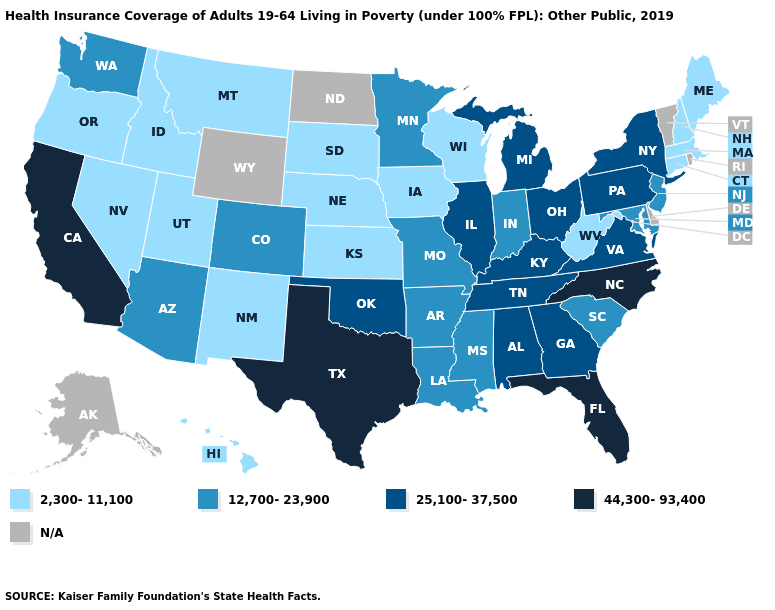Which states have the highest value in the USA?
Answer briefly. California, Florida, North Carolina, Texas. Which states have the lowest value in the MidWest?
Be succinct. Iowa, Kansas, Nebraska, South Dakota, Wisconsin. Which states have the lowest value in the Northeast?
Concise answer only. Connecticut, Maine, Massachusetts, New Hampshire. What is the value of Louisiana?
Write a very short answer. 12,700-23,900. Does the map have missing data?
Quick response, please. Yes. What is the value of Nebraska?
Answer briefly. 2,300-11,100. What is the value of Oregon?
Write a very short answer. 2,300-11,100. What is the value of Mississippi?
Give a very brief answer. 12,700-23,900. Name the states that have a value in the range 12,700-23,900?
Keep it brief. Arizona, Arkansas, Colorado, Indiana, Louisiana, Maryland, Minnesota, Mississippi, Missouri, New Jersey, South Carolina, Washington. What is the highest value in the USA?
Concise answer only. 44,300-93,400. Does Texas have the highest value in the USA?
Write a very short answer. Yes. Name the states that have a value in the range 25,100-37,500?
Be succinct. Alabama, Georgia, Illinois, Kentucky, Michigan, New York, Ohio, Oklahoma, Pennsylvania, Tennessee, Virginia. Name the states that have a value in the range 2,300-11,100?
Be succinct. Connecticut, Hawaii, Idaho, Iowa, Kansas, Maine, Massachusetts, Montana, Nebraska, Nevada, New Hampshire, New Mexico, Oregon, South Dakota, Utah, West Virginia, Wisconsin. 